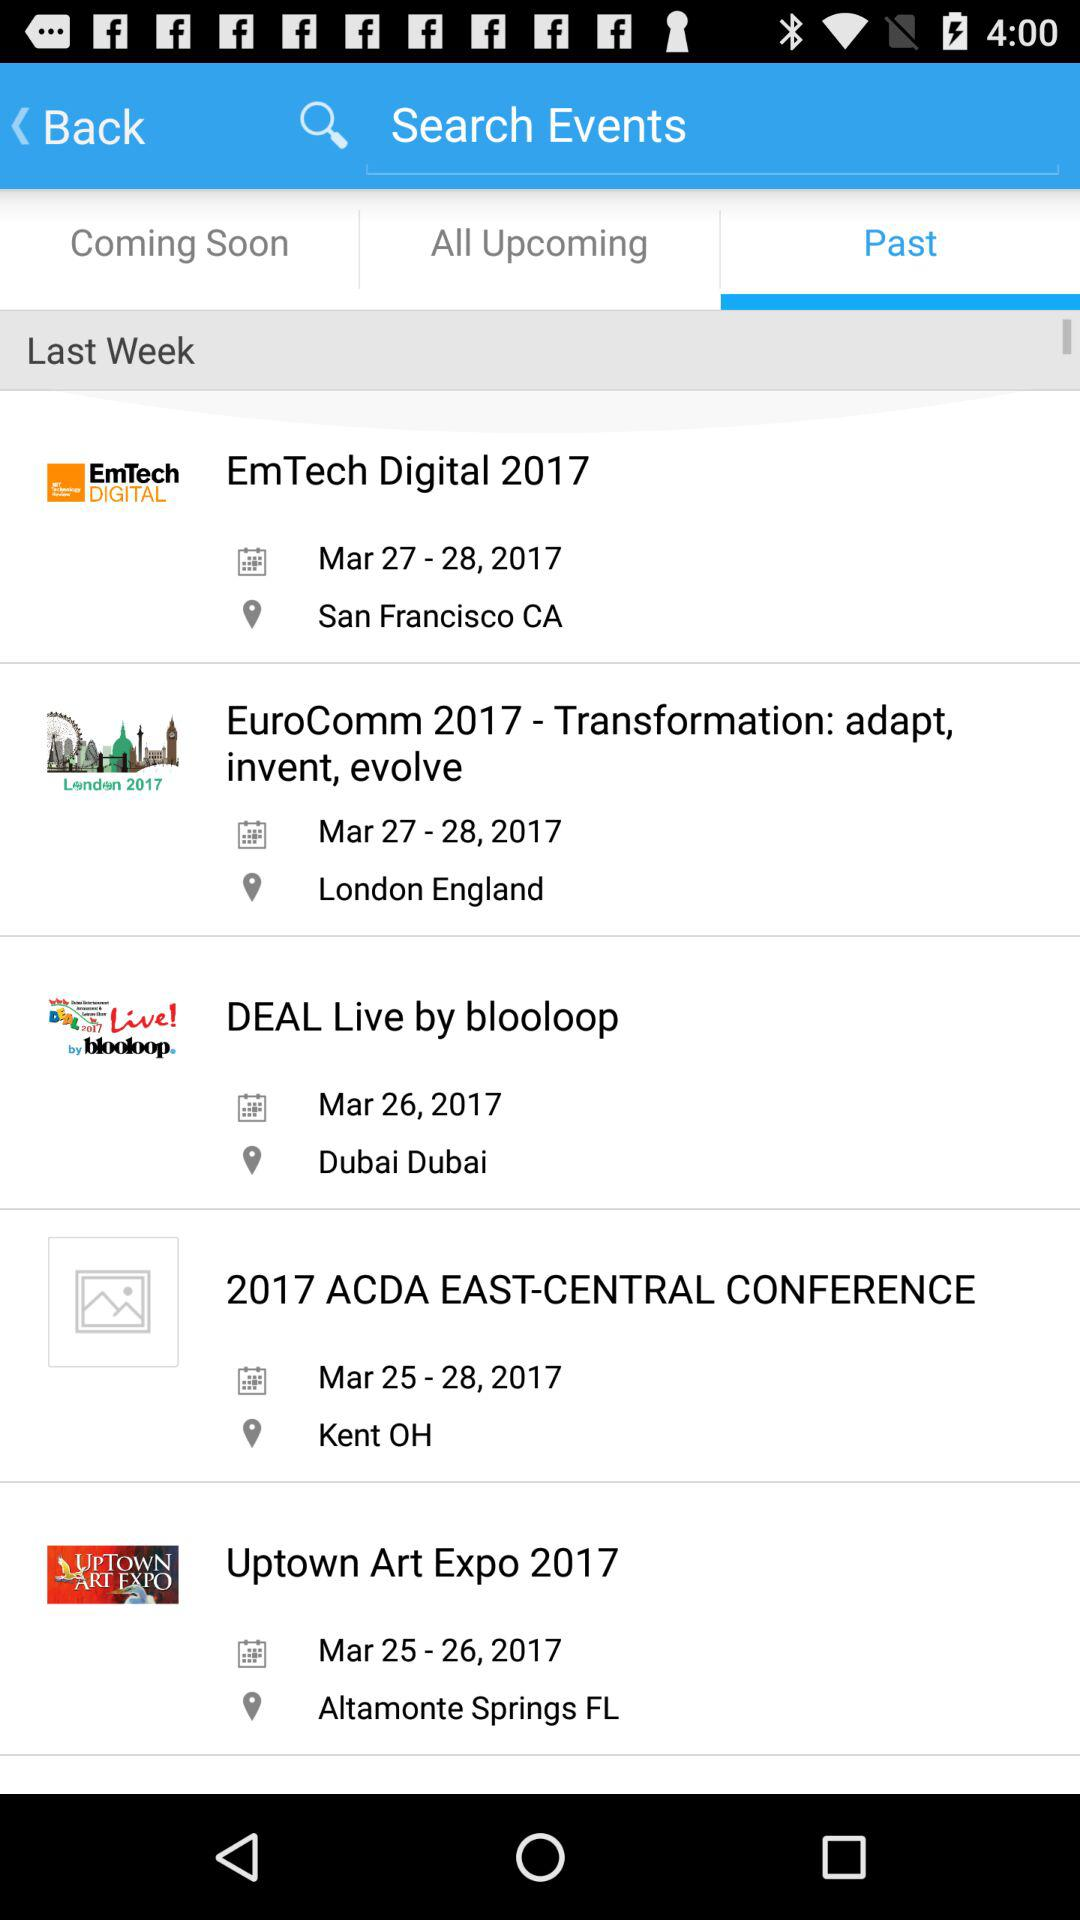Where will the "2017 ACDA EAST-CENTRAL CONFERENCE" take place? The "2017 ACDA EAST-CENTRAL CONFERENCE" will take place in Kent, OH. 